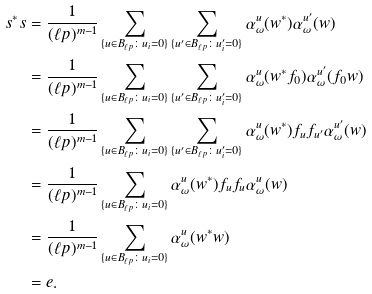<formula> <loc_0><loc_0><loc_500><loc_500>s ^ { * } s & = \frac { 1 } { ( \ell p ) ^ { m - 1 } } \sum _ { \{ u \in B _ { \ell p } \colon u _ { i } = 0 \} } \sum _ { \{ u ^ { \prime } \in B _ { \ell p } \colon u _ { i } ^ { \prime } = 0 \} } \alpha _ { \omega } ^ { u } ( w ^ { * } ) \alpha _ { \omega } ^ { u ^ { \prime } } ( w ) \\ & = \frac { 1 } { ( \ell p ) ^ { m - 1 } } \sum _ { \{ u \in B _ { \ell p } \colon u _ { i } = 0 \} } \sum _ { \{ u ^ { \prime } \in B _ { \ell p } \colon u _ { i } ^ { \prime } = 0 \} } \alpha _ { \omega } ^ { u } ( w ^ { * } f _ { 0 } ) \alpha _ { \omega } ^ { u ^ { \prime } } ( f _ { 0 } w ) \\ & = \frac { 1 } { ( \ell p ) ^ { m - 1 } } \sum _ { \{ u \in B _ { \ell p } \colon u _ { i } = 0 \} } \sum _ { \{ u ^ { \prime } \in B _ { \ell p } \colon u _ { i } ^ { \prime } = 0 \} } \alpha _ { \omega } ^ { u } ( w ^ { * } ) f _ { u } f _ { u ^ { \prime } } \alpha _ { \omega } ^ { u ^ { \prime } } ( w ) \\ & = \frac { 1 } { ( \ell p ) ^ { m - 1 } } \sum _ { \{ u \in B _ { \ell p } \colon u _ { i } = 0 \} } \alpha _ { \omega } ^ { u } ( w ^ { * } ) f _ { u } f _ { u } \alpha _ { \omega } ^ { u } ( w ) \\ & = \frac { 1 } { ( \ell p ) ^ { m - 1 } } \sum _ { \{ u \in B _ { \ell p } \colon u _ { i } = 0 \} } \alpha _ { \omega } ^ { u } ( w ^ { * } w ) \\ & = e .</formula> 